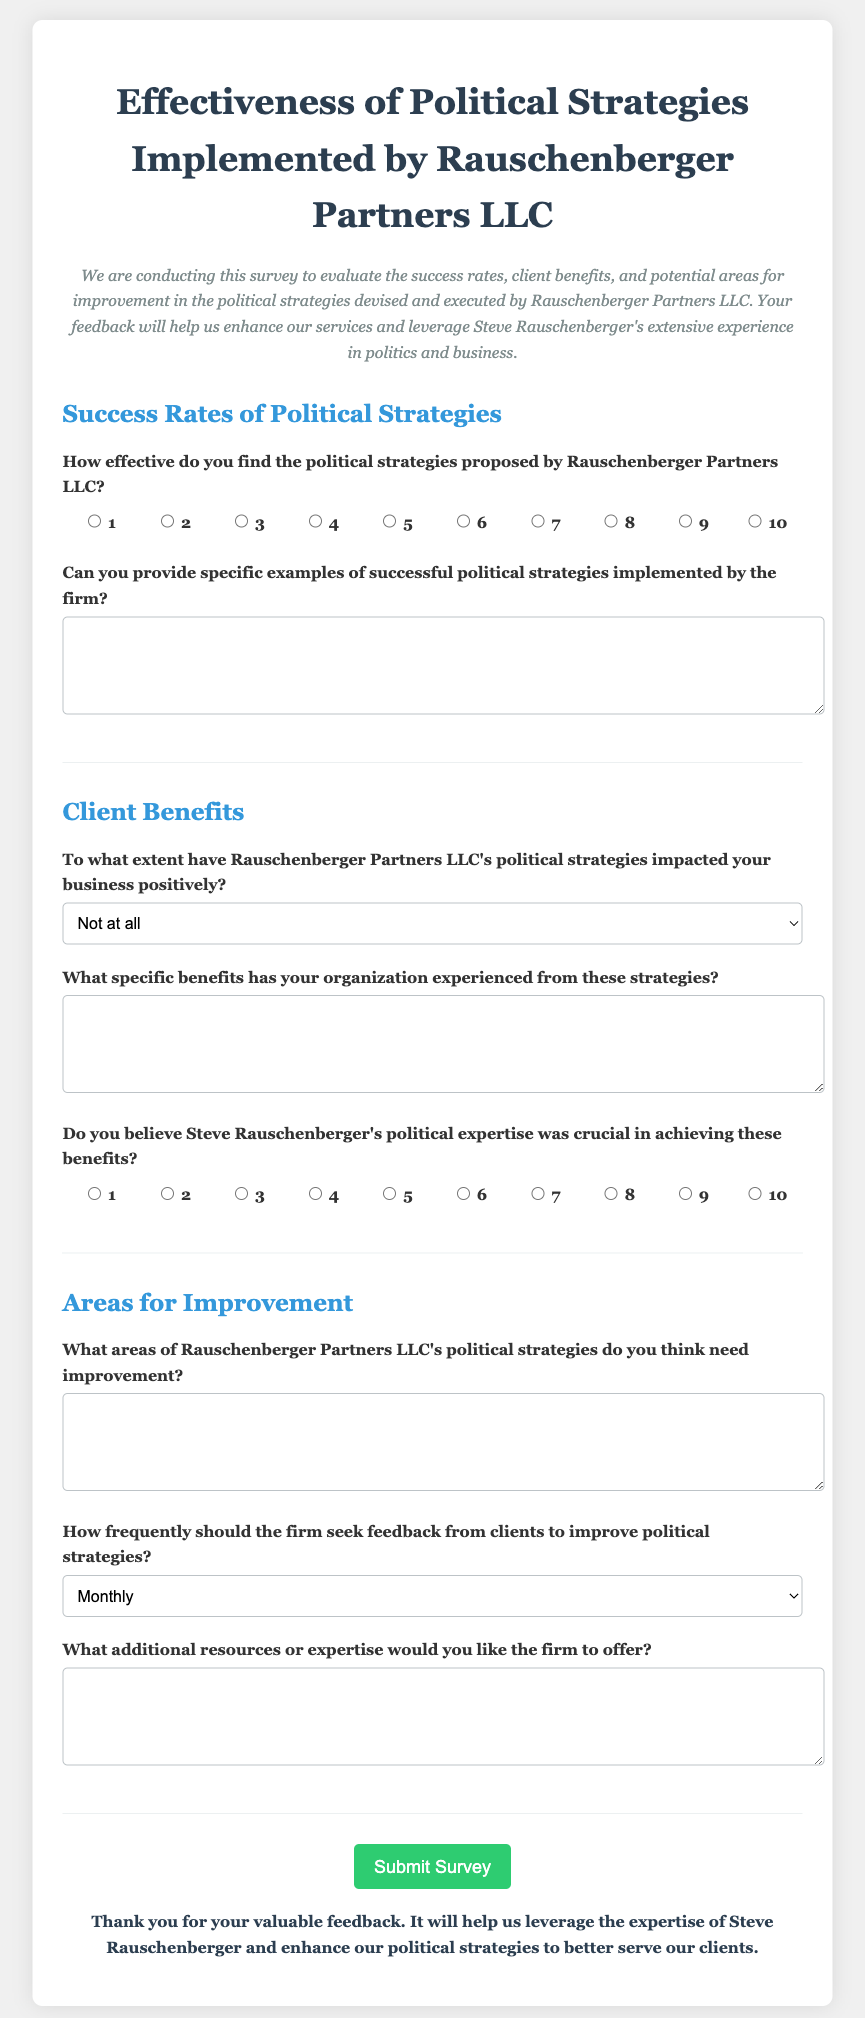What is the title of the survey? The title of the survey is presented prominently at the top of the document.
Answer: Effectiveness of Political Strategies Implemented by Rauschenberger Partners LLC What is the purpose of the survey? The purpose is explained in the introductory paragraph where the nature of the feedback is discussed.
Answer: Evaluate the success rates, client benefits, and potential areas for improvement How many sections are there in the survey? The document includes clear section headings, which indicate the organization of the content.
Answer: Three sections What scale is used to measure the effectiveness of political strategies? The document specifies a scale for rating, which indicates the range of effectiveness.
Answer: 1 to 10 Which feedback frequency option is available? The frequency options for seeking client feedback are listed in the areas for improvement section.
Answer: Monthly What type of input does the survey ask for in regard to specific benefits? The survey prompts respondents to provide qualitative data regarding the impact of strategies.
Answer: Text area What does the submit button say? The wording of the button is specified directly in the document.
Answer: Submit Survey What color is the submit button? The document describes the styling of the button, including its color scheme.
Answer: Green How is the survey form styled in terms of font? The document specifies the font type used throughout the form.
Answer: Georgia 